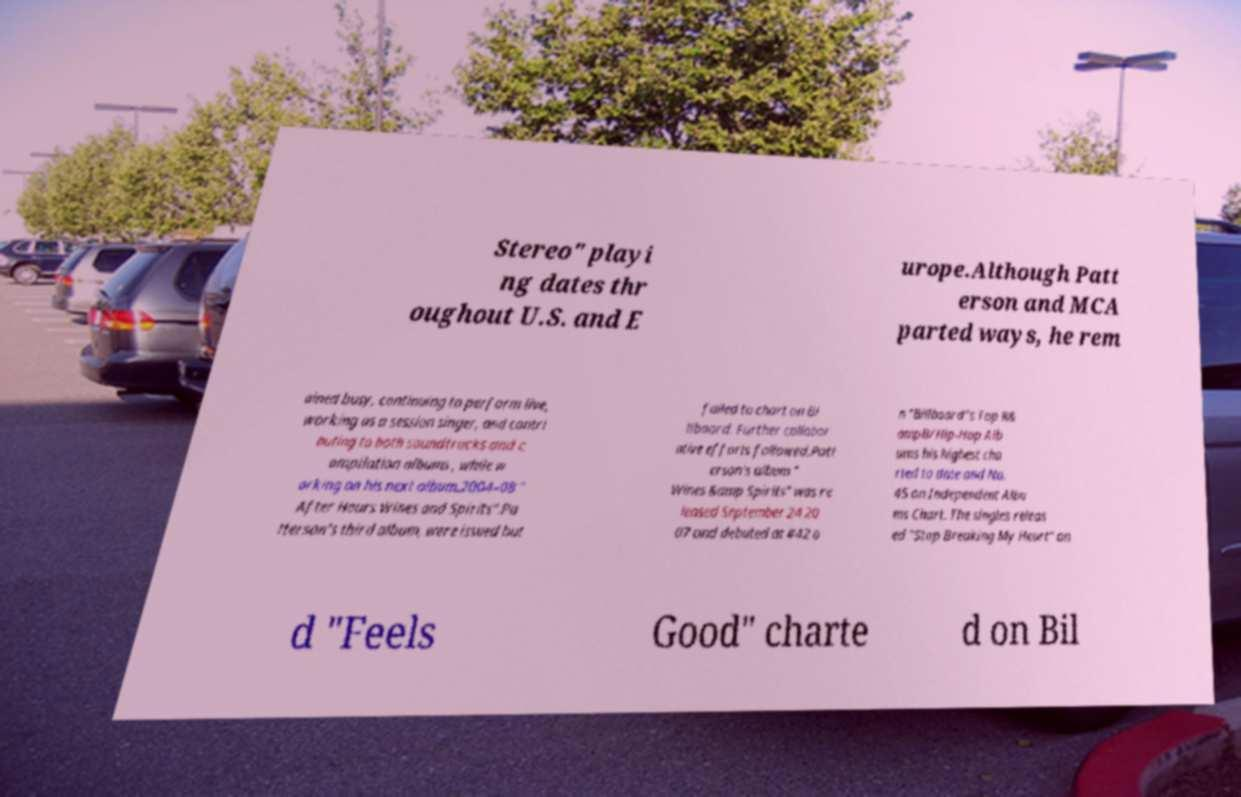What messages or text are displayed in this image? I need them in a readable, typed format. Stereo" playi ng dates thr oughout U.S. and E urope.Although Patt erson and MCA parted ways, he rem ained busy, continuing to perform live, working as a session singer, and contri buting to both soundtracks and c ompilation albums , while w orking on his next album.2004–08 " After Hours Wines and Spirits".Pa tterson's third album, were issued but failed to chart on Bi llboard. Further collabor ative efforts followed.Patt erson's album " Wines &amp Spirits" was re leased September 24 20 07 and debuted at #42 o n "Billboard"s Top R& ampB/Hip-Hop Alb ums his highest cha rted to date and No. 45 on Independent Albu ms Chart. The singles releas ed "Stop Breaking My Heart" an d "Feels Good" charte d on Bil 